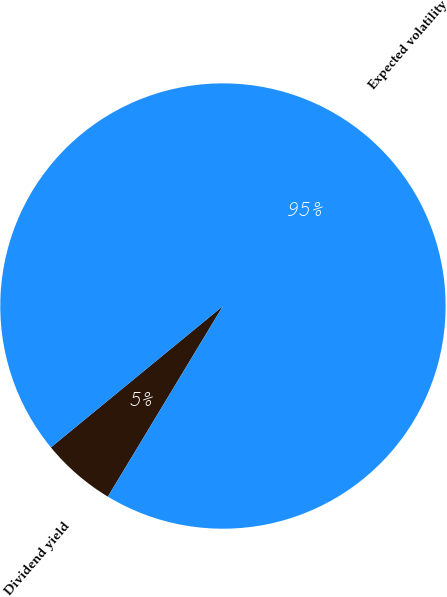Convert chart to OTSL. <chart><loc_0><loc_0><loc_500><loc_500><pie_chart><fcel>Dividend yield<fcel>Expected volatility<nl><fcel>5.41%<fcel>94.59%<nl></chart> 